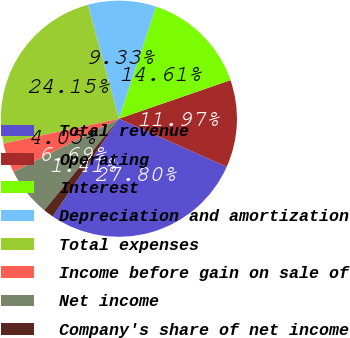Convert chart. <chart><loc_0><loc_0><loc_500><loc_500><pie_chart><fcel>Total revenue<fcel>Operating<fcel>Interest<fcel>Depreciation and amortization<fcel>Total expenses<fcel>Income before gain on sale of<fcel>Net income<fcel>Company's share of net income<nl><fcel>27.8%<fcel>11.97%<fcel>14.61%<fcel>9.33%<fcel>24.15%<fcel>4.05%<fcel>6.69%<fcel>1.41%<nl></chart> 